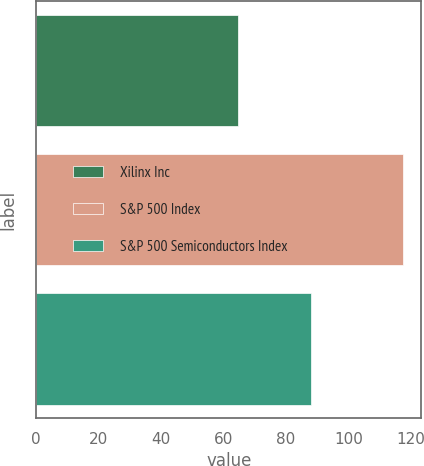Convert chart to OTSL. <chart><loc_0><loc_0><loc_500><loc_500><bar_chart><fcel>Xilinx Inc<fcel>S&P 500 Index<fcel>S&P 500 Semiconductors Index<nl><fcel>64.79<fcel>117.58<fcel>88.16<nl></chart> 